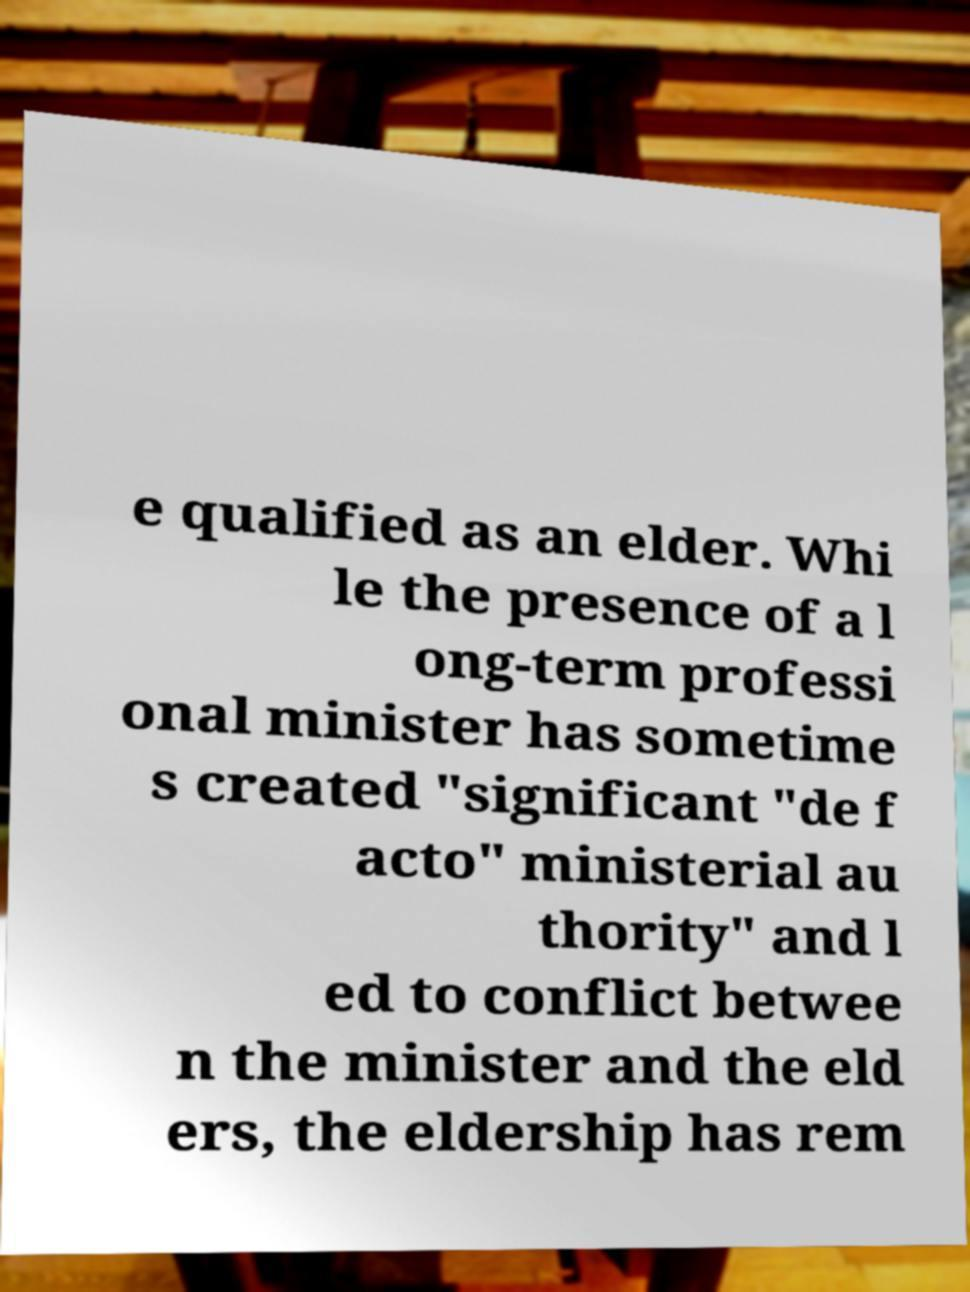Can you accurately transcribe the text from the provided image for me? e qualified as an elder. Whi le the presence of a l ong-term professi onal minister has sometime s created "significant "de f acto" ministerial au thority" and l ed to conflict betwee n the minister and the eld ers, the eldership has rem 